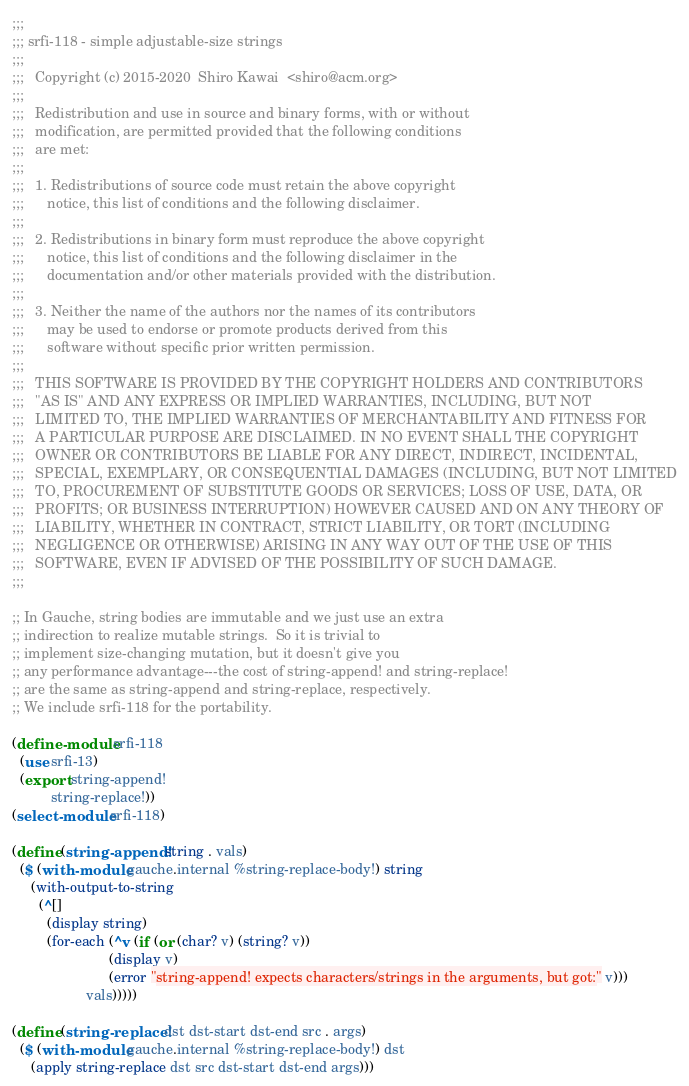Convert code to text. <code><loc_0><loc_0><loc_500><loc_500><_Scheme_>;;;
;;; srfi-118 - simple adjustable-size strings
;;;
;;;   Copyright (c) 2015-2020  Shiro Kawai  <shiro@acm.org>
;;;
;;;   Redistribution and use in source and binary forms, with or without
;;;   modification, are permitted provided that the following conditions
;;;   are met:
;;;
;;;   1. Redistributions of source code must retain the above copyright
;;;      notice, this list of conditions and the following disclaimer.
;;;
;;;   2. Redistributions in binary form must reproduce the above copyright
;;;      notice, this list of conditions and the following disclaimer in the
;;;      documentation and/or other materials provided with the distribution.
;;;
;;;   3. Neither the name of the authors nor the names of its contributors
;;;      may be used to endorse or promote products derived from this
;;;      software without specific prior written permission.
;;;
;;;   THIS SOFTWARE IS PROVIDED BY THE COPYRIGHT HOLDERS AND CONTRIBUTORS
;;;   "AS IS" AND ANY EXPRESS OR IMPLIED WARRANTIES, INCLUDING, BUT NOT
;;;   LIMITED TO, THE IMPLIED WARRANTIES OF MERCHANTABILITY AND FITNESS FOR
;;;   A PARTICULAR PURPOSE ARE DISCLAIMED. IN NO EVENT SHALL THE COPYRIGHT
;;;   OWNER OR CONTRIBUTORS BE LIABLE FOR ANY DIRECT, INDIRECT, INCIDENTAL,
;;;   SPECIAL, EXEMPLARY, OR CONSEQUENTIAL DAMAGES (INCLUDING, BUT NOT LIMITED
;;;   TO, PROCUREMENT OF SUBSTITUTE GOODS OR SERVICES; LOSS OF USE, DATA, OR
;;;   PROFITS; OR BUSINESS INTERRUPTION) HOWEVER CAUSED AND ON ANY THEORY OF
;;;   LIABILITY, WHETHER IN CONTRACT, STRICT LIABILITY, OR TORT (INCLUDING
;;;   NEGLIGENCE OR OTHERWISE) ARISING IN ANY WAY OUT OF THE USE OF THIS
;;;   SOFTWARE, EVEN IF ADVISED OF THE POSSIBILITY OF SUCH DAMAGE.
;;;

;; In Gauche, string bodies are immutable and we just use an extra
;; indirection to realize mutable strings.  So it is trivial to
;; implement size-changing mutation, but it doesn't give you
;; any performance advantage---the cost of string-append! and string-replace!
;; are the same as string-append and string-replace, respectively.
;; We include srfi-118 for the portability.

(define-module srfi-118
  (use srfi-13)
  (export string-append!
          string-replace!))
(select-module srfi-118)

(define (string-append! string . vals)
  ($ (with-module gauche.internal %string-replace-body!) string
     (with-output-to-string
       (^[]
         (display string)
         (for-each (^v (if (or (char? v) (string? v))
                         (display v)
                         (error "string-append! expects characters/strings in the arguments, but got:" v)))
                   vals)))))

(define (string-replace! dst dst-start dst-end src . args)
  ($ (with-module gauche.internal %string-replace-body!) dst
     (apply string-replace dst src dst-start dst-end args)))
</code> 